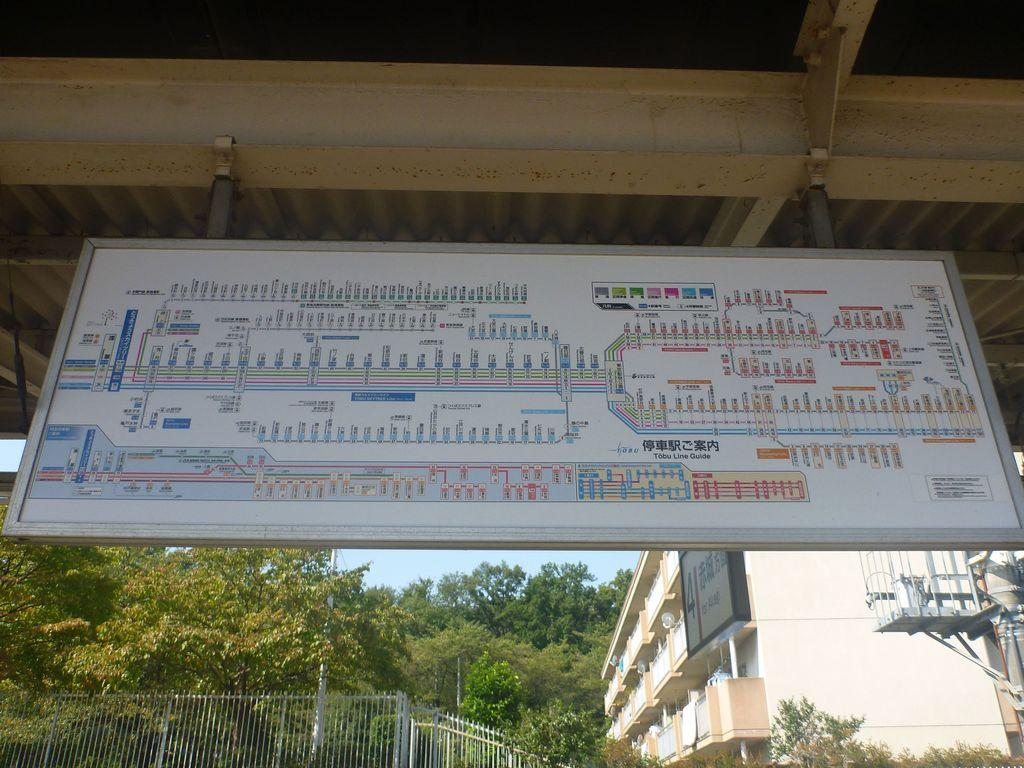What is depicted on the board in the image? There is a map on the board in the image. What can be seen in the background of the image? There is fencing, a building, and trees visible in the background of the image. What is the color of the sky in the image? The sky is blue in the image. How many slaves are visible in the image? There are no slaves present in the image. What type of calculator can be seen on the board with the map? There is no calculator present on the board with the map in the image. 